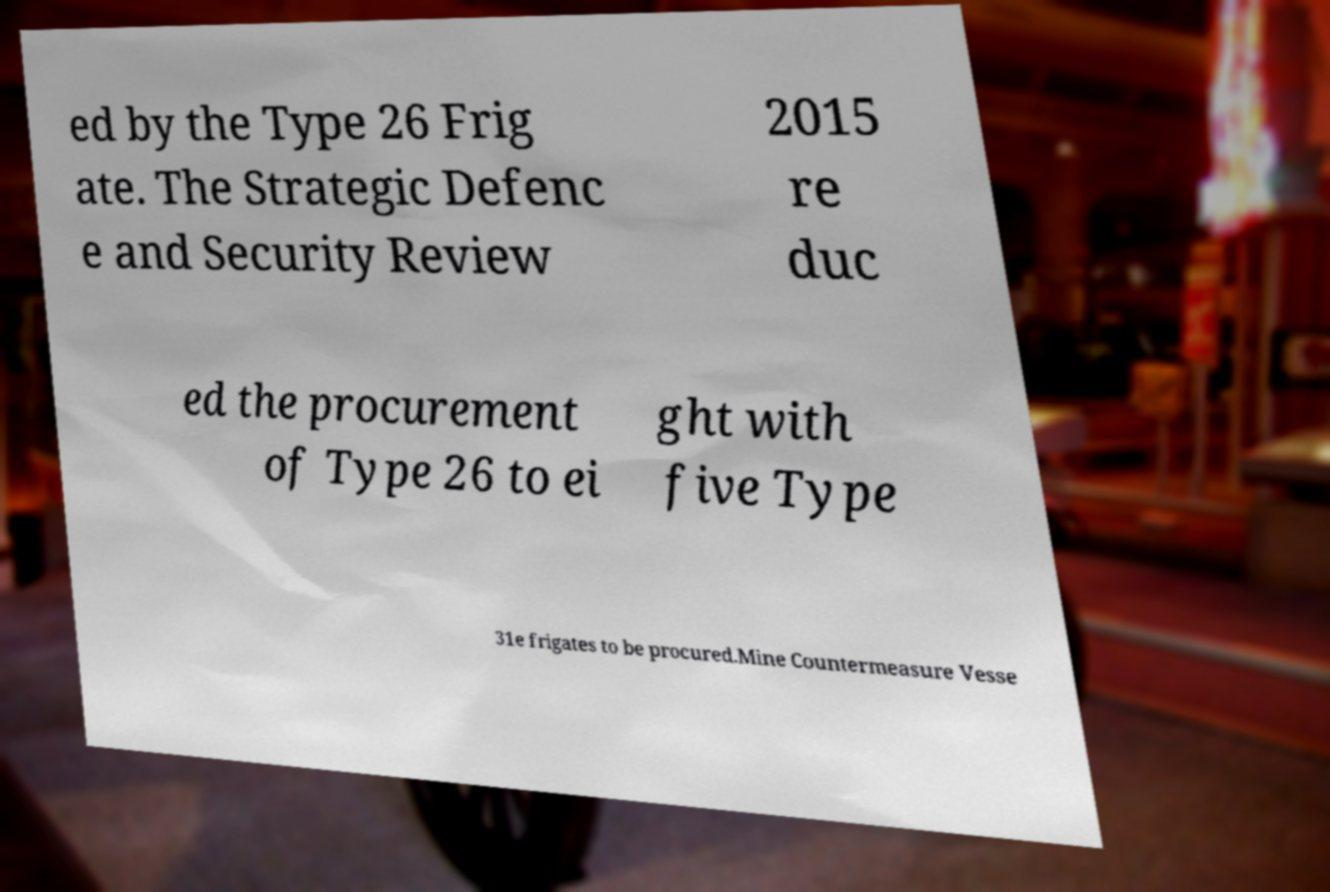For documentation purposes, I need the text within this image transcribed. Could you provide that? ed by the Type 26 Frig ate. The Strategic Defenc e and Security Review 2015 re duc ed the procurement of Type 26 to ei ght with five Type 31e frigates to be procured.Mine Countermeasure Vesse 